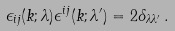<formula> <loc_0><loc_0><loc_500><loc_500>\epsilon _ { i j } ( { k } ; \lambda ) \epsilon ^ { i j } ( { k } ; \lambda ^ { \prime } ) = 2 \delta _ { \lambda \lambda ^ { \prime } } \, .</formula> 